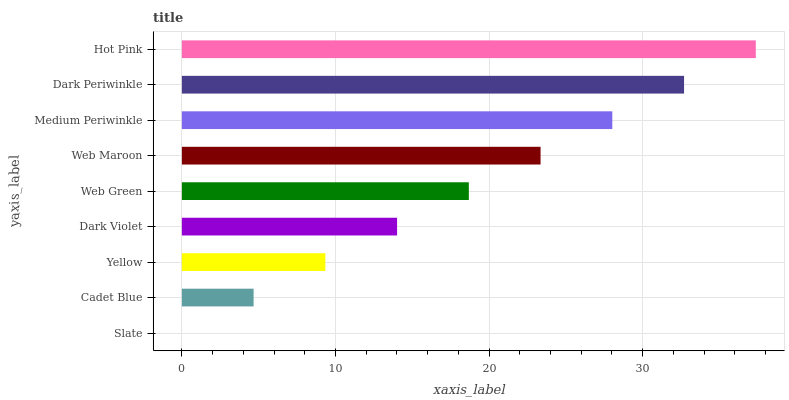Is Slate the minimum?
Answer yes or no. Yes. Is Hot Pink the maximum?
Answer yes or no. Yes. Is Cadet Blue the minimum?
Answer yes or no. No. Is Cadet Blue the maximum?
Answer yes or no. No. Is Cadet Blue greater than Slate?
Answer yes or no. Yes. Is Slate less than Cadet Blue?
Answer yes or no. Yes. Is Slate greater than Cadet Blue?
Answer yes or no. No. Is Cadet Blue less than Slate?
Answer yes or no. No. Is Web Green the high median?
Answer yes or no. Yes. Is Web Green the low median?
Answer yes or no. Yes. Is Dark Periwinkle the high median?
Answer yes or no. No. Is Slate the low median?
Answer yes or no. No. 